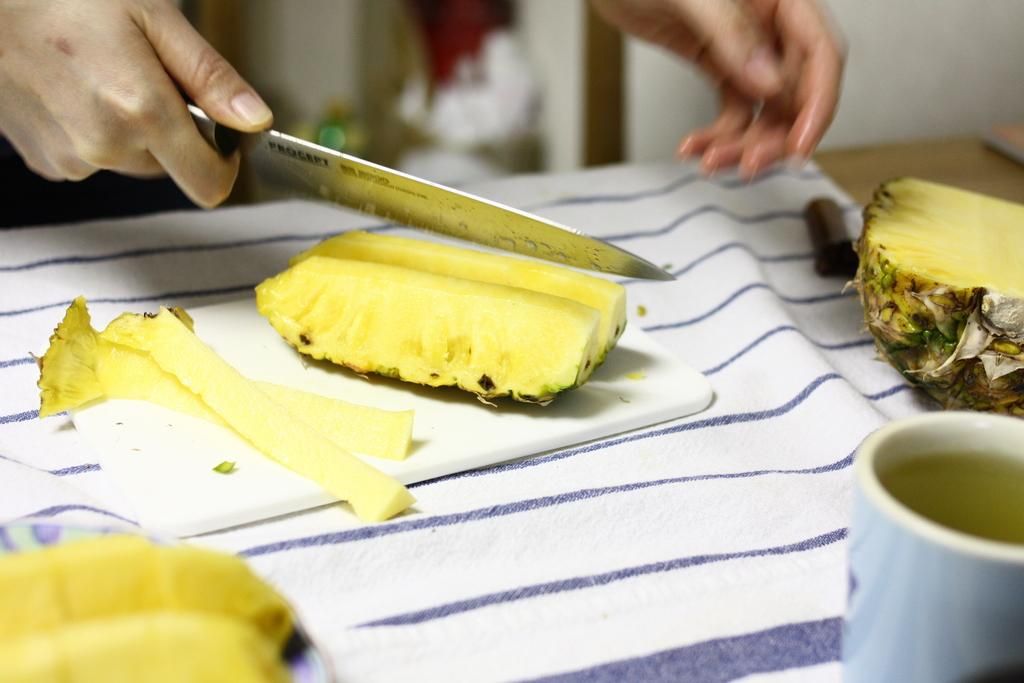What fruit is on the table in the image? There is a pineapple on the table in the image. What object is being held by the person in the image? The person is holding a knife. What type of container is visible in the image? There is a cup visible in the image. How much money is being exchanged between the person and the giraffe in the image? There is no giraffe present in the image, and therefore no exchange of money can be observed. What type of growth is visible on the pineapple in the image? The image does not show any growth on the pineapple; it only shows the fruit itself. 